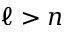Convert formula to latex. <formula><loc_0><loc_0><loc_500><loc_500>\ell > n</formula> 